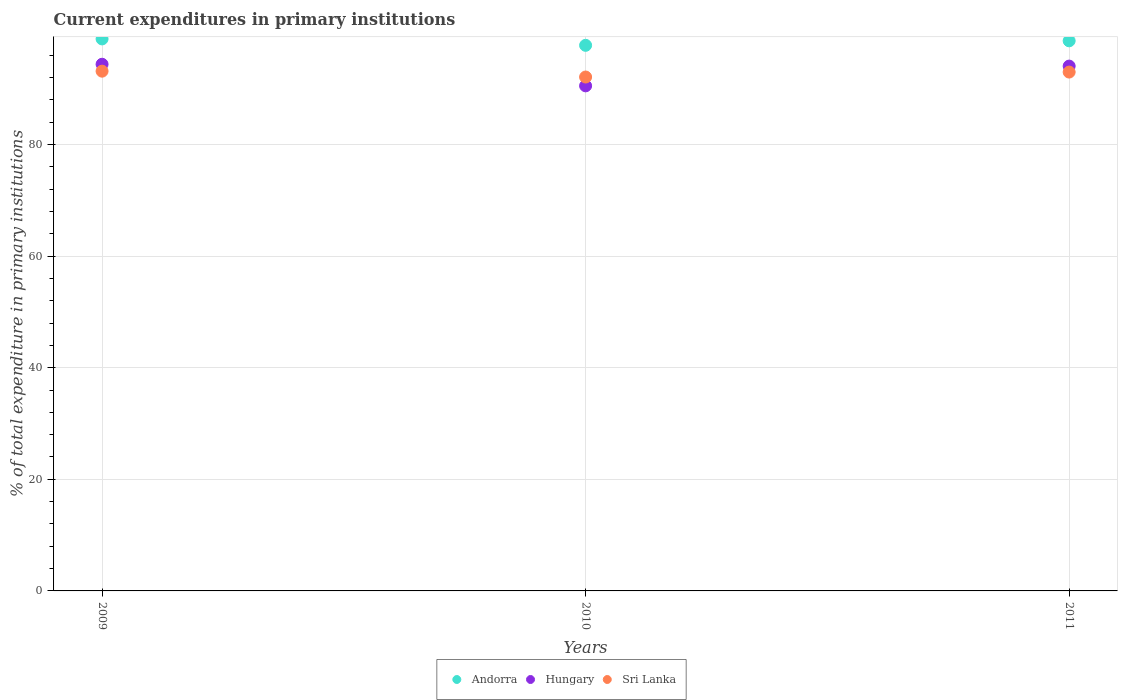What is the current expenditures in primary institutions in Hungary in 2009?
Your response must be concise. 94.38. Across all years, what is the maximum current expenditures in primary institutions in Hungary?
Ensure brevity in your answer.  94.38. Across all years, what is the minimum current expenditures in primary institutions in Hungary?
Give a very brief answer. 90.51. In which year was the current expenditures in primary institutions in Sri Lanka minimum?
Give a very brief answer. 2010. What is the total current expenditures in primary institutions in Hungary in the graph?
Your answer should be compact. 278.95. What is the difference between the current expenditures in primary institutions in Sri Lanka in 2009 and that in 2010?
Give a very brief answer. 1.05. What is the difference between the current expenditures in primary institutions in Sri Lanka in 2011 and the current expenditures in primary institutions in Andorra in 2009?
Your answer should be compact. -5.94. What is the average current expenditures in primary institutions in Andorra per year?
Provide a succinct answer. 98.43. In the year 2011, what is the difference between the current expenditures in primary institutions in Andorra and current expenditures in primary institutions in Sri Lanka?
Ensure brevity in your answer.  5.6. What is the ratio of the current expenditures in primary institutions in Andorra in 2009 to that in 2010?
Offer a very short reply. 1.01. Is the current expenditures in primary institutions in Sri Lanka in 2010 less than that in 2011?
Make the answer very short. Yes. What is the difference between the highest and the second highest current expenditures in primary institutions in Andorra?
Keep it short and to the point. 0.34. What is the difference between the highest and the lowest current expenditures in primary institutions in Andorra?
Your answer should be compact. 1.15. In how many years, is the current expenditures in primary institutions in Hungary greater than the average current expenditures in primary institutions in Hungary taken over all years?
Your answer should be very brief. 2. Is it the case that in every year, the sum of the current expenditures in primary institutions in Andorra and current expenditures in primary institutions in Sri Lanka  is greater than the current expenditures in primary institutions in Hungary?
Offer a very short reply. Yes. Does the current expenditures in primary institutions in Hungary monotonically increase over the years?
Give a very brief answer. No. Is the current expenditures in primary institutions in Sri Lanka strictly greater than the current expenditures in primary institutions in Hungary over the years?
Provide a succinct answer. No. Is the current expenditures in primary institutions in Hungary strictly less than the current expenditures in primary institutions in Sri Lanka over the years?
Provide a short and direct response. No. How many dotlines are there?
Your answer should be compact. 3. What is the difference between two consecutive major ticks on the Y-axis?
Give a very brief answer. 20. Does the graph contain grids?
Provide a succinct answer. Yes. Where does the legend appear in the graph?
Keep it short and to the point. Bottom center. What is the title of the graph?
Your response must be concise. Current expenditures in primary institutions. Does "Malta" appear as one of the legend labels in the graph?
Offer a very short reply. No. What is the label or title of the X-axis?
Provide a succinct answer. Years. What is the label or title of the Y-axis?
Your response must be concise. % of total expenditure in primary institutions. What is the % of total expenditure in primary institutions of Andorra in 2009?
Provide a short and direct response. 98.92. What is the % of total expenditure in primary institutions of Hungary in 2009?
Your answer should be compact. 94.38. What is the % of total expenditure in primary institutions of Sri Lanka in 2009?
Your response must be concise. 93.14. What is the % of total expenditure in primary institutions in Andorra in 2010?
Give a very brief answer. 97.77. What is the % of total expenditure in primary institutions in Hungary in 2010?
Provide a short and direct response. 90.51. What is the % of total expenditure in primary institutions in Sri Lanka in 2010?
Ensure brevity in your answer.  92.09. What is the % of total expenditure in primary institutions of Andorra in 2011?
Give a very brief answer. 98.58. What is the % of total expenditure in primary institutions in Hungary in 2011?
Provide a succinct answer. 94.05. What is the % of total expenditure in primary institutions in Sri Lanka in 2011?
Provide a short and direct response. 92.98. Across all years, what is the maximum % of total expenditure in primary institutions in Andorra?
Your response must be concise. 98.92. Across all years, what is the maximum % of total expenditure in primary institutions of Hungary?
Your response must be concise. 94.38. Across all years, what is the maximum % of total expenditure in primary institutions of Sri Lanka?
Your answer should be compact. 93.14. Across all years, what is the minimum % of total expenditure in primary institutions of Andorra?
Give a very brief answer. 97.77. Across all years, what is the minimum % of total expenditure in primary institutions of Hungary?
Offer a terse response. 90.51. Across all years, what is the minimum % of total expenditure in primary institutions in Sri Lanka?
Your answer should be compact. 92.09. What is the total % of total expenditure in primary institutions of Andorra in the graph?
Your response must be concise. 295.28. What is the total % of total expenditure in primary institutions in Hungary in the graph?
Your answer should be compact. 278.95. What is the total % of total expenditure in primary institutions of Sri Lanka in the graph?
Offer a terse response. 278.22. What is the difference between the % of total expenditure in primary institutions of Andorra in 2009 and that in 2010?
Keep it short and to the point. 1.15. What is the difference between the % of total expenditure in primary institutions in Hungary in 2009 and that in 2010?
Provide a short and direct response. 3.87. What is the difference between the % of total expenditure in primary institutions of Sri Lanka in 2009 and that in 2010?
Your response must be concise. 1.05. What is the difference between the % of total expenditure in primary institutions in Andorra in 2009 and that in 2011?
Ensure brevity in your answer.  0.34. What is the difference between the % of total expenditure in primary institutions in Hungary in 2009 and that in 2011?
Offer a terse response. 0.33. What is the difference between the % of total expenditure in primary institutions of Sri Lanka in 2009 and that in 2011?
Provide a succinct answer. 0.16. What is the difference between the % of total expenditure in primary institutions of Andorra in 2010 and that in 2011?
Offer a very short reply. -0.81. What is the difference between the % of total expenditure in primary institutions of Hungary in 2010 and that in 2011?
Provide a succinct answer. -3.54. What is the difference between the % of total expenditure in primary institutions of Sri Lanka in 2010 and that in 2011?
Keep it short and to the point. -0.89. What is the difference between the % of total expenditure in primary institutions of Andorra in 2009 and the % of total expenditure in primary institutions of Hungary in 2010?
Offer a terse response. 8.41. What is the difference between the % of total expenditure in primary institutions in Andorra in 2009 and the % of total expenditure in primary institutions in Sri Lanka in 2010?
Give a very brief answer. 6.83. What is the difference between the % of total expenditure in primary institutions of Hungary in 2009 and the % of total expenditure in primary institutions of Sri Lanka in 2010?
Your answer should be very brief. 2.29. What is the difference between the % of total expenditure in primary institutions in Andorra in 2009 and the % of total expenditure in primary institutions in Hungary in 2011?
Provide a succinct answer. 4.87. What is the difference between the % of total expenditure in primary institutions of Andorra in 2009 and the % of total expenditure in primary institutions of Sri Lanka in 2011?
Provide a succinct answer. 5.94. What is the difference between the % of total expenditure in primary institutions in Hungary in 2009 and the % of total expenditure in primary institutions in Sri Lanka in 2011?
Your response must be concise. 1.4. What is the difference between the % of total expenditure in primary institutions in Andorra in 2010 and the % of total expenditure in primary institutions in Hungary in 2011?
Offer a very short reply. 3.72. What is the difference between the % of total expenditure in primary institutions of Andorra in 2010 and the % of total expenditure in primary institutions of Sri Lanka in 2011?
Your answer should be very brief. 4.79. What is the difference between the % of total expenditure in primary institutions in Hungary in 2010 and the % of total expenditure in primary institutions in Sri Lanka in 2011?
Provide a short and direct response. -2.47. What is the average % of total expenditure in primary institutions of Andorra per year?
Keep it short and to the point. 98.43. What is the average % of total expenditure in primary institutions of Hungary per year?
Offer a terse response. 92.98. What is the average % of total expenditure in primary institutions in Sri Lanka per year?
Your response must be concise. 92.74. In the year 2009, what is the difference between the % of total expenditure in primary institutions of Andorra and % of total expenditure in primary institutions of Hungary?
Provide a succinct answer. 4.54. In the year 2009, what is the difference between the % of total expenditure in primary institutions of Andorra and % of total expenditure in primary institutions of Sri Lanka?
Ensure brevity in your answer.  5.78. In the year 2009, what is the difference between the % of total expenditure in primary institutions in Hungary and % of total expenditure in primary institutions in Sri Lanka?
Your answer should be compact. 1.24. In the year 2010, what is the difference between the % of total expenditure in primary institutions in Andorra and % of total expenditure in primary institutions in Hungary?
Ensure brevity in your answer.  7.26. In the year 2010, what is the difference between the % of total expenditure in primary institutions in Andorra and % of total expenditure in primary institutions in Sri Lanka?
Ensure brevity in your answer.  5.68. In the year 2010, what is the difference between the % of total expenditure in primary institutions of Hungary and % of total expenditure in primary institutions of Sri Lanka?
Provide a succinct answer. -1.58. In the year 2011, what is the difference between the % of total expenditure in primary institutions in Andorra and % of total expenditure in primary institutions in Hungary?
Make the answer very short. 4.53. In the year 2011, what is the difference between the % of total expenditure in primary institutions in Andorra and % of total expenditure in primary institutions in Sri Lanka?
Offer a very short reply. 5.6. In the year 2011, what is the difference between the % of total expenditure in primary institutions of Hungary and % of total expenditure in primary institutions of Sri Lanka?
Ensure brevity in your answer.  1.07. What is the ratio of the % of total expenditure in primary institutions of Andorra in 2009 to that in 2010?
Provide a succinct answer. 1.01. What is the ratio of the % of total expenditure in primary institutions of Hungary in 2009 to that in 2010?
Ensure brevity in your answer.  1.04. What is the ratio of the % of total expenditure in primary institutions of Sri Lanka in 2009 to that in 2010?
Keep it short and to the point. 1.01. What is the ratio of the % of total expenditure in primary institutions in Andorra in 2010 to that in 2011?
Ensure brevity in your answer.  0.99. What is the ratio of the % of total expenditure in primary institutions in Hungary in 2010 to that in 2011?
Your response must be concise. 0.96. What is the difference between the highest and the second highest % of total expenditure in primary institutions of Andorra?
Keep it short and to the point. 0.34. What is the difference between the highest and the second highest % of total expenditure in primary institutions in Hungary?
Offer a very short reply. 0.33. What is the difference between the highest and the second highest % of total expenditure in primary institutions of Sri Lanka?
Give a very brief answer. 0.16. What is the difference between the highest and the lowest % of total expenditure in primary institutions of Andorra?
Provide a succinct answer. 1.15. What is the difference between the highest and the lowest % of total expenditure in primary institutions in Hungary?
Give a very brief answer. 3.87. What is the difference between the highest and the lowest % of total expenditure in primary institutions of Sri Lanka?
Offer a terse response. 1.05. 